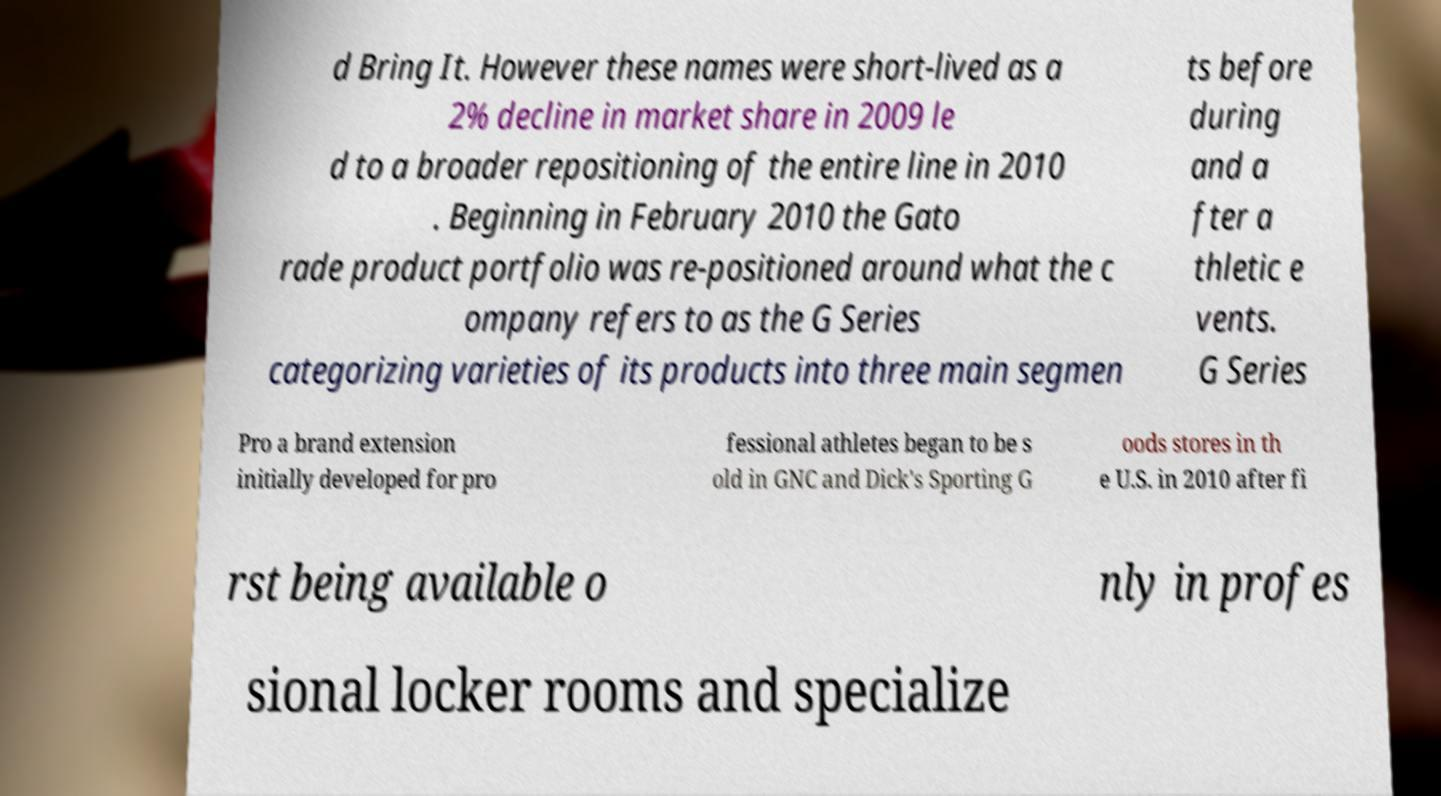I need the written content from this picture converted into text. Can you do that? d Bring It. However these names were short-lived as a 2% decline in market share in 2009 le d to a broader repositioning of the entire line in 2010 . Beginning in February 2010 the Gato rade product portfolio was re-positioned around what the c ompany refers to as the G Series categorizing varieties of its products into three main segmen ts before during and a fter a thletic e vents. G Series Pro a brand extension initially developed for pro fessional athletes began to be s old in GNC and Dick's Sporting G oods stores in th e U.S. in 2010 after fi rst being available o nly in profes sional locker rooms and specialize 